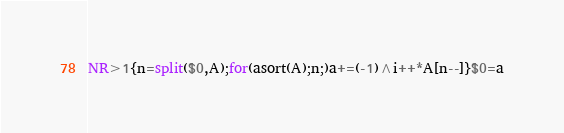Convert code to text. <code><loc_0><loc_0><loc_500><loc_500><_Awk_>NR>1{n=split($0,A);for(asort(A);n;)a+=(-1)^i++*A[n--]}$0=a</code> 